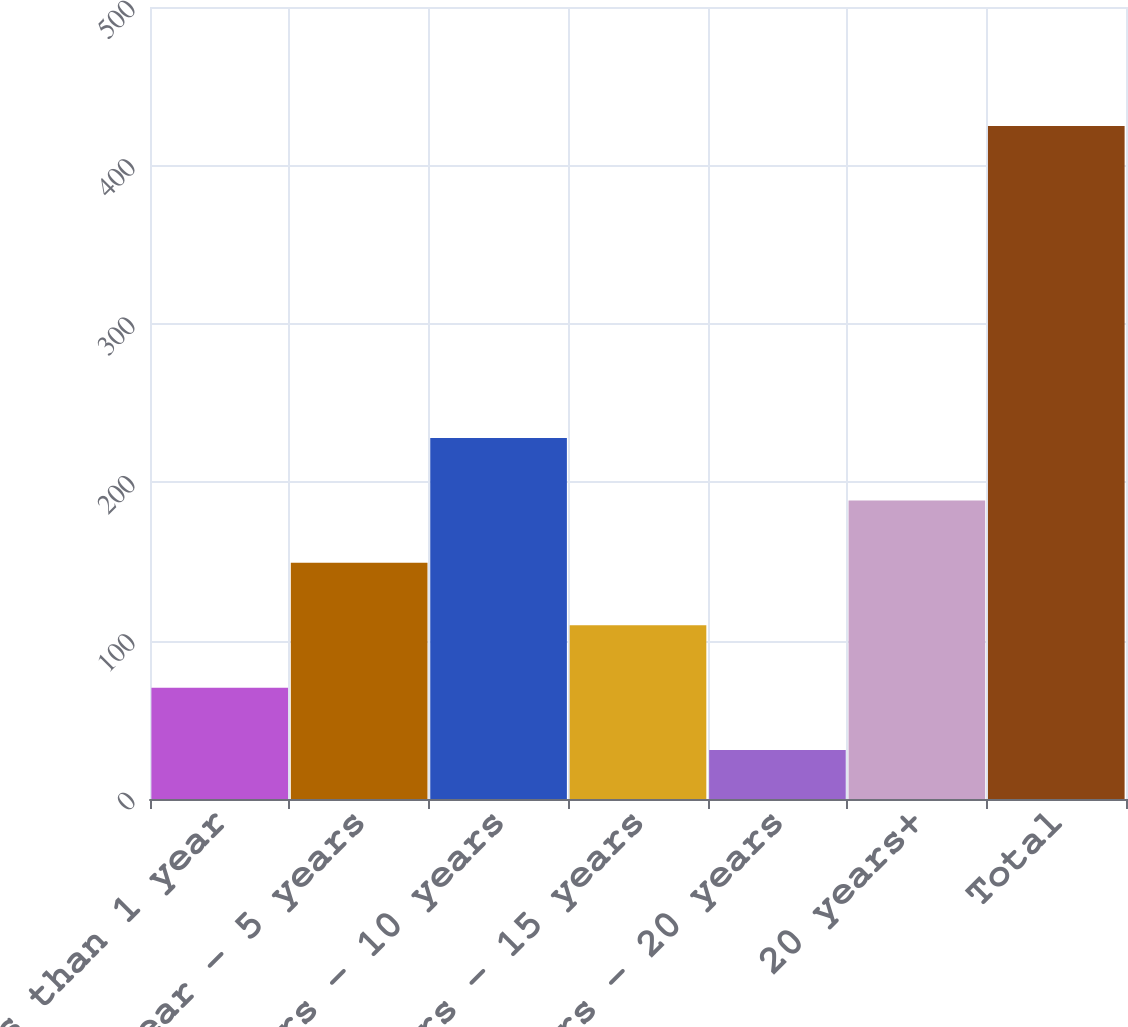<chart> <loc_0><loc_0><loc_500><loc_500><bar_chart><fcel>less than 1 year<fcel>1 year - 5 years<fcel>5 years - 10 years<fcel>10 years - 15 years<fcel>15 years - 20 years<fcel>20 years+<fcel>Total<nl><fcel>70.29<fcel>149.07<fcel>227.85<fcel>109.68<fcel>30.9<fcel>188.46<fcel>424.8<nl></chart> 